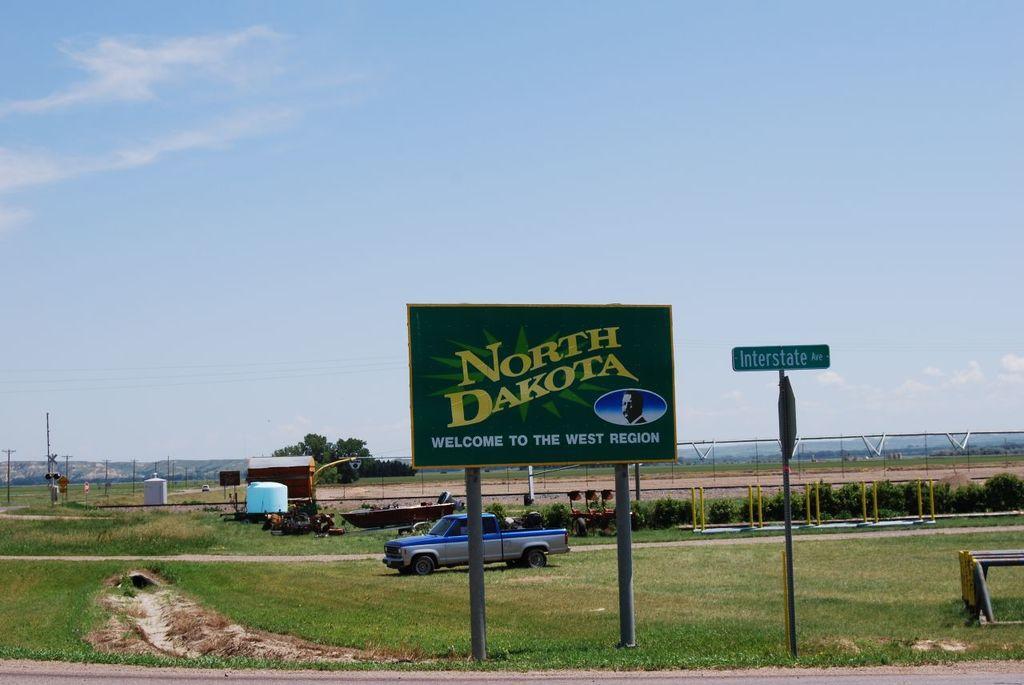Describe this image in one or two sentences. In this picture we can see there are poles with boards attached to it. Behind the boards, there is a vehicle, grass, it looks like a shed, poles, trees, hills and the sky. On the right side of the image, there is an object. 